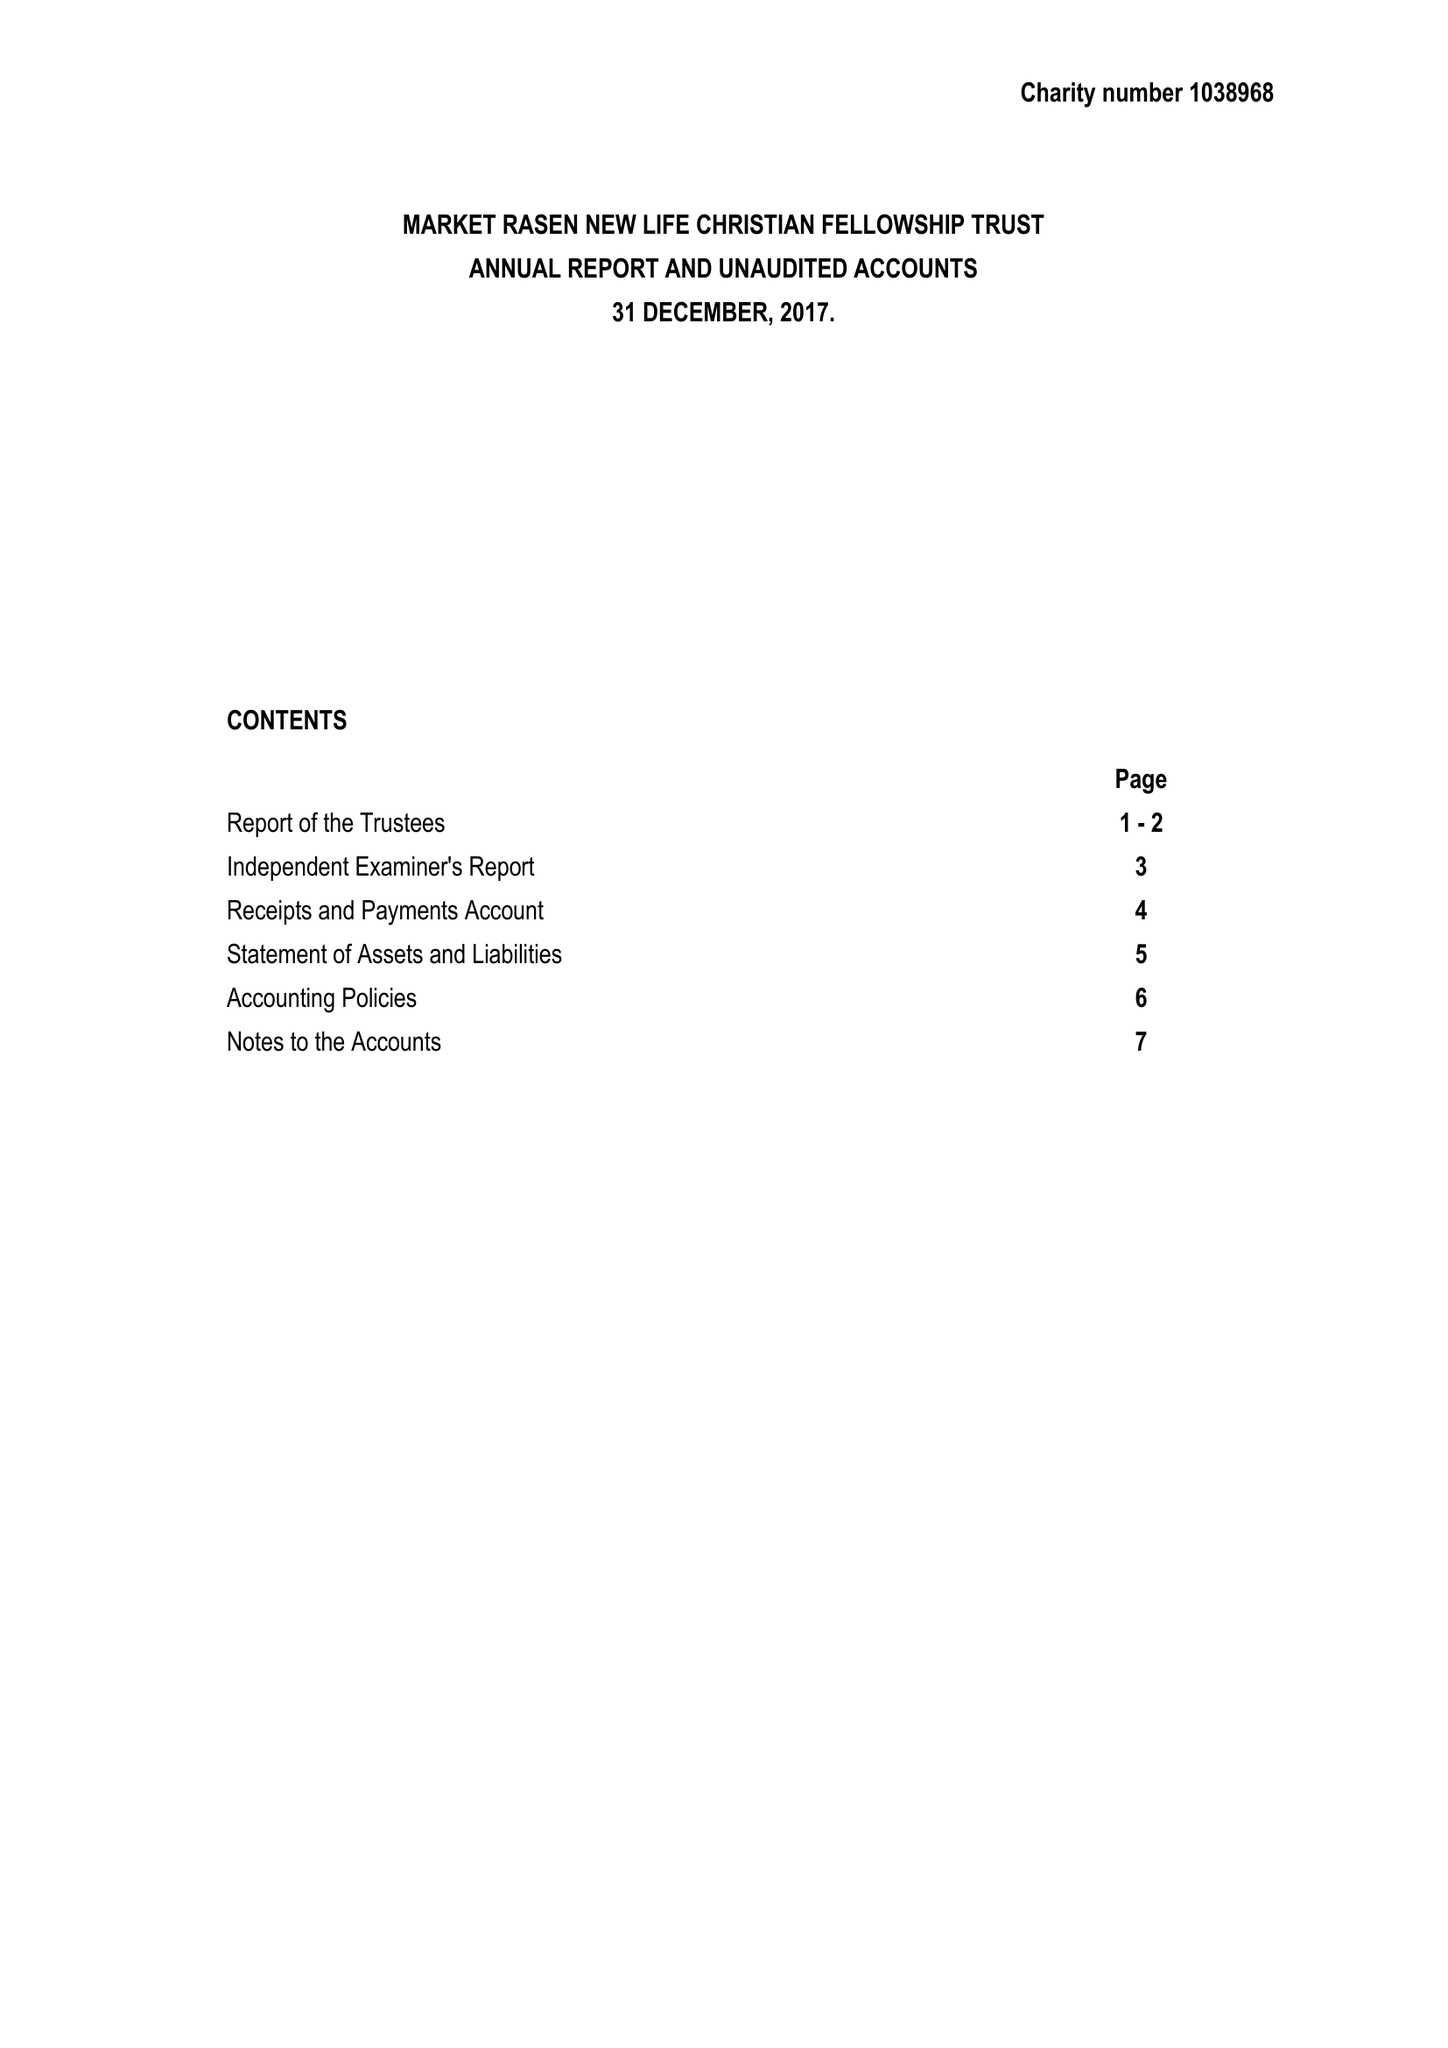What is the value for the income_annually_in_british_pounds?
Answer the question using a single word or phrase. 83406.00 